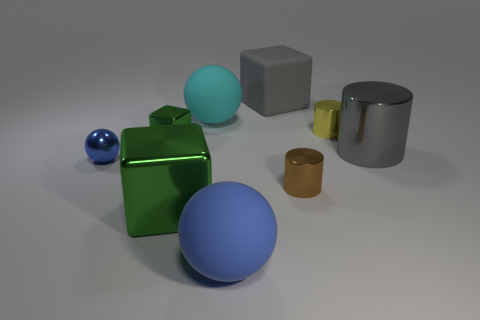What number of large blocks are behind the tiny shiny cube to the left of the blue thing that is in front of the big green object?
Your response must be concise. 1. What number of other things are there of the same material as the small cube
Your answer should be compact. 5. There is a cube that is the same size as the brown cylinder; what is its material?
Offer a very short reply. Metal. Do the matte ball in front of the tiny brown cylinder and the sphere that is left of the big green metallic object have the same color?
Ensure brevity in your answer.  Yes. Are there any gray shiny objects of the same shape as the brown metallic thing?
Give a very brief answer. Yes. What is the shape of the brown metal object that is the same size as the yellow metallic cylinder?
Provide a succinct answer. Cylinder. What number of tiny cylinders have the same color as the small ball?
Your answer should be very brief. 0. How big is the gray thing that is to the right of the gray cube?
Keep it short and to the point. Large. How many cyan rubber balls have the same size as the yellow cylinder?
Provide a short and direct response. 0. There is a big cylinder that is made of the same material as the small green block; what is its color?
Make the answer very short. Gray. 